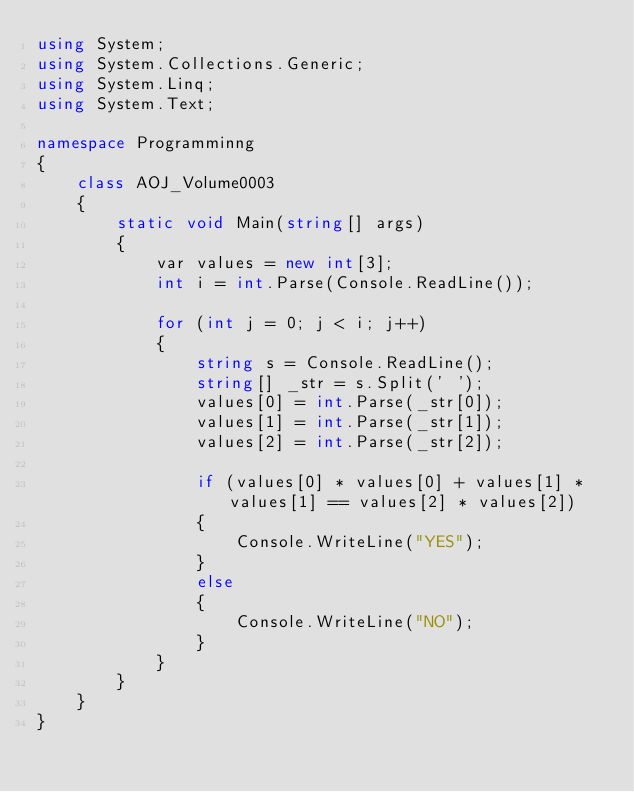Convert code to text. <code><loc_0><loc_0><loc_500><loc_500><_C#_>using System;
using System.Collections.Generic;
using System.Linq;
using System.Text;

namespace Programminng
{
    class AOJ_Volume0003
    {
        static void Main(string[] args)
        {
            var values = new int[3];
            int i = int.Parse(Console.ReadLine());

            for (int j = 0; j < i; j++)
            {
                string s = Console.ReadLine();
                string[] _str = s.Split(' ');
                values[0] = int.Parse(_str[0]);
                values[1] = int.Parse(_str[1]);
                values[2] = int.Parse(_str[2]);

                if (values[0] * values[0] + values[1] * values[1] == values[2] * values[2])
                {
                    Console.WriteLine("YES");
                }
                else
                {
                    Console.WriteLine("NO");
                }
            }
        }
    }
}</code> 